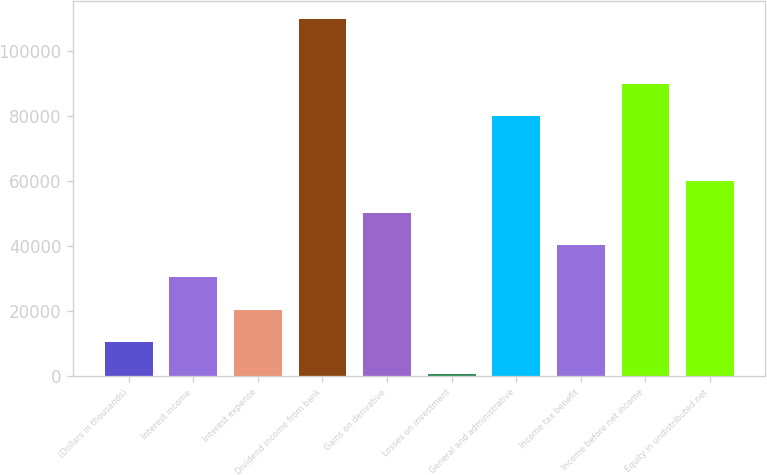<chart> <loc_0><loc_0><loc_500><loc_500><bar_chart><fcel>(Dollars in thousands)<fcel>Interest income<fcel>Interest expense<fcel>Dividend income from bank<fcel>Gains on derivative<fcel>Losses on investment<fcel>General and administrative<fcel>Income tax benefit<fcel>Income before net income<fcel>Equity in undistributed net<nl><fcel>10502.2<fcel>30390.6<fcel>20446.4<fcel>109944<fcel>50279<fcel>558<fcel>80111.6<fcel>40334.8<fcel>90055.8<fcel>60223.2<nl></chart> 